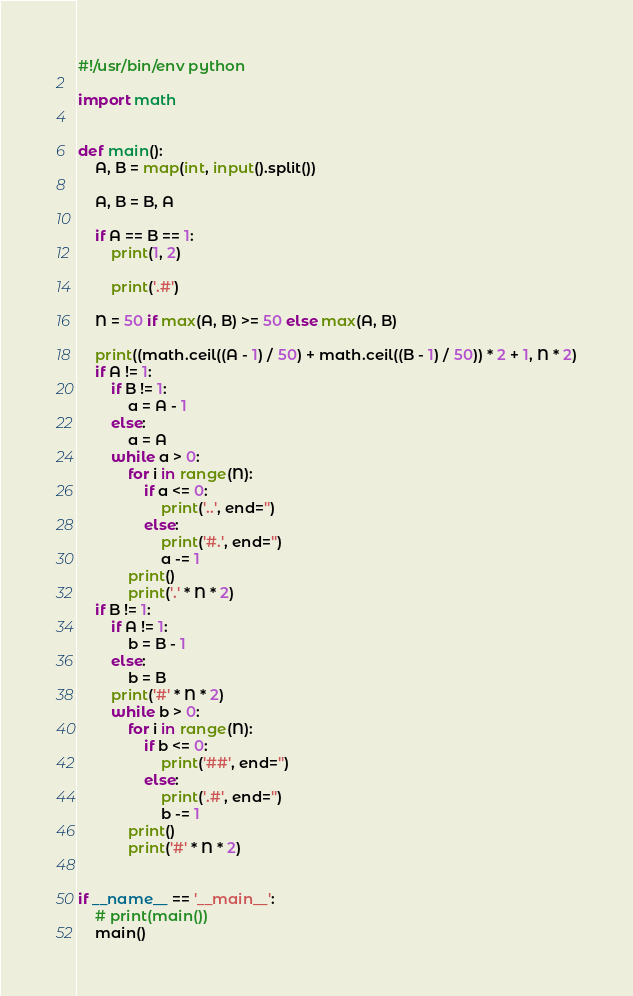<code> <loc_0><loc_0><loc_500><loc_500><_Python_>#!/usr/bin/env python

import math


def main():
    A, B = map(int, input().split())

    A, B = B, A

    if A == B == 1:
        print(1, 2)

        print('.#')

    N = 50 if max(A, B) >= 50 else max(A, B)

    print((math.ceil((A - 1) / 50) + math.ceil((B - 1) / 50)) * 2 + 1, N * 2)
    if A != 1:
        if B != 1:
            a = A - 1
        else:
            a = A
        while a > 0:
            for i in range(N):
                if a <= 0:
                    print('..', end='')
                else:
                    print('#.', end='')
                    a -= 1
            print()
            print('.' * N * 2)
    if B != 1:
        if A != 1:
            b = B - 1
        else:
            b = B
        print('#' * N * 2)
        while b > 0:
            for i in range(N):
                if b <= 0:
                    print('##', end='')
                else:
                    print('.#', end='')
                    b -= 1
            print()
            print('#' * N * 2)


if __name__ == '__main__':
    # print(main())
    main()</code> 